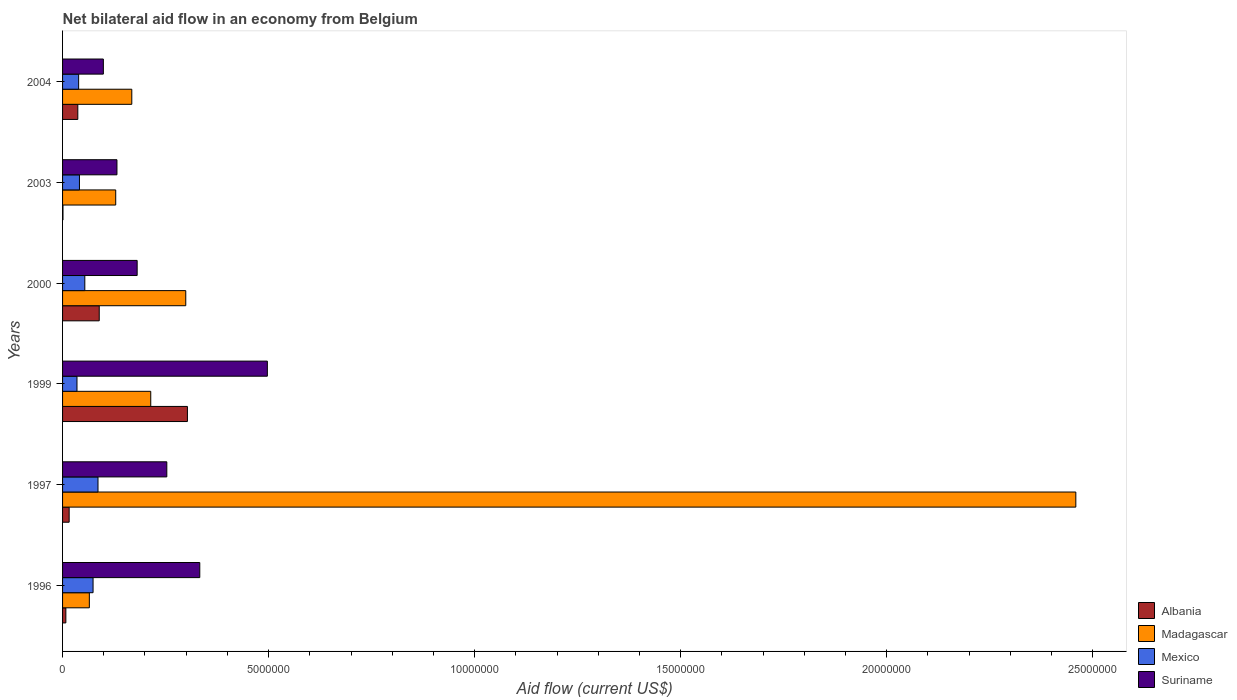How many different coloured bars are there?
Make the answer very short. 4. How many groups of bars are there?
Ensure brevity in your answer.  6. How many bars are there on the 1st tick from the top?
Ensure brevity in your answer.  4. What is the net bilateral aid flow in Mexico in 1996?
Your response must be concise. 7.40e+05. Across all years, what is the maximum net bilateral aid flow in Albania?
Ensure brevity in your answer.  3.03e+06. What is the total net bilateral aid flow in Albania in the graph?
Offer a very short reply. 4.54e+06. What is the difference between the net bilateral aid flow in Suriname in 1996 and that in 2003?
Give a very brief answer. 2.01e+06. What is the difference between the net bilateral aid flow in Madagascar in 2004 and the net bilateral aid flow in Albania in 1999?
Make the answer very short. -1.35e+06. What is the average net bilateral aid flow in Albania per year?
Provide a short and direct response. 7.57e+05. In the year 2003, what is the difference between the net bilateral aid flow in Mexico and net bilateral aid flow in Albania?
Keep it short and to the point. 4.00e+05. In how many years, is the net bilateral aid flow in Suriname greater than 5000000 US$?
Provide a short and direct response. 0. What is the ratio of the net bilateral aid flow in Suriname in 1997 to that in 2004?
Offer a very short reply. 2.56. What is the difference between the highest and the second highest net bilateral aid flow in Albania?
Make the answer very short. 2.14e+06. What is the difference between the highest and the lowest net bilateral aid flow in Madagascar?
Give a very brief answer. 2.39e+07. In how many years, is the net bilateral aid flow in Madagascar greater than the average net bilateral aid flow in Madagascar taken over all years?
Provide a succinct answer. 1. Is it the case that in every year, the sum of the net bilateral aid flow in Albania and net bilateral aid flow in Mexico is greater than the sum of net bilateral aid flow in Madagascar and net bilateral aid flow in Suriname?
Offer a very short reply. Yes. Is it the case that in every year, the sum of the net bilateral aid flow in Albania and net bilateral aid flow in Madagascar is greater than the net bilateral aid flow in Suriname?
Keep it short and to the point. No. How many bars are there?
Your response must be concise. 24. Are all the bars in the graph horizontal?
Provide a short and direct response. Yes. What is the difference between two consecutive major ticks on the X-axis?
Your response must be concise. 5.00e+06. Does the graph contain any zero values?
Make the answer very short. No. Where does the legend appear in the graph?
Your answer should be compact. Bottom right. How many legend labels are there?
Ensure brevity in your answer.  4. What is the title of the graph?
Offer a very short reply. Net bilateral aid flow in an economy from Belgium. What is the label or title of the Y-axis?
Offer a very short reply. Years. What is the Aid flow (current US$) in Albania in 1996?
Give a very brief answer. 8.00e+04. What is the Aid flow (current US$) in Madagascar in 1996?
Keep it short and to the point. 6.50e+05. What is the Aid flow (current US$) of Mexico in 1996?
Ensure brevity in your answer.  7.40e+05. What is the Aid flow (current US$) in Suriname in 1996?
Offer a terse response. 3.33e+06. What is the Aid flow (current US$) in Madagascar in 1997?
Ensure brevity in your answer.  2.46e+07. What is the Aid flow (current US$) in Mexico in 1997?
Your answer should be very brief. 8.60e+05. What is the Aid flow (current US$) in Suriname in 1997?
Provide a succinct answer. 2.53e+06. What is the Aid flow (current US$) of Albania in 1999?
Give a very brief answer. 3.03e+06. What is the Aid flow (current US$) of Madagascar in 1999?
Your response must be concise. 2.14e+06. What is the Aid flow (current US$) in Mexico in 1999?
Make the answer very short. 3.50e+05. What is the Aid flow (current US$) of Suriname in 1999?
Offer a very short reply. 4.97e+06. What is the Aid flow (current US$) of Albania in 2000?
Your answer should be very brief. 8.90e+05. What is the Aid flow (current US$) in Madagascar in 2000?
Make the answer very short. 2.99e+06. What is the Aid flow (current US$) in Mexico in 2000?
Offer a very short reply. 5.40e+05. What is the Aid flow (current US$) of Suriname in 2000?
Provide a succinct answer. 1.81e+06. What is the Aid flow (current US$) in Madagascar in 2003?
Give a very brief answer. 1.29e+06. What is the Aid flow (current US$) in Mexico in 2003?
Your response must be concise. 4.10e+05. What is the Aid flow (current US$) of Suriname in 2003?
Your response must be concise. 1.32e+06. What is the Aid flow (current US$) of Madagascar in 2004?
Provide a succinct answer. 1.68e+06. What is the Aid flow (current US$) of Suriname in 2004?
Provide a short and direct response. 9.90e+05. Across all years, what is the maximum Aid flow (current US$) in Albania?
Your answer should be compact. 3.03e+06. Across all years, what is the maximum Aid flow (current US$) in Madagascar?
Keep it short and to the point. 2.46e+07. Across all years, what is the maximum Aid flow (current US$) of Mexico?
Give a very brief answer. 8.60e+05. Across all years, what is the maximum Aid flow (current US$) in Suriname?
Your response must be concise. 4.97e+06. Across all years, what is the minimum Aid flow (current US$) in Madagascar?
Keep it short and to the point. 6.50e+05. Across all years, what is the minimum Aid flow (current US$) in Suriname?
Provide a succinct answer. 9.90e+05. What is the total Aid flow (current US$) in Albania in the graph?
Keep it short and to the point. 4.54e+06. What is the total Aid flow (current US$) of Madagascar in the graph?
Ensure brevity in your answer.  3.33e+07. What is the total Aid flow (current US$) in Mexico in the graph?
Offer a very short reply. 3.29e+06. What is the total Aid flow (current US$) of Suriname in the graph?
Ensure brevity in your answer.  1.50e+07. What is the difference between the Aid flow (current US$) of Madagascar in 1996 and that in 1997?
Your answer should be very brief. -2.39e+07. What is the difference between the Aid flow (current US$) in Suriname in 1996 and that in 1997?
Your answer should be very brief. 8.00e+05. What is the difference between the Aid flow (current US$) in Albania in 1996 and that in 1999?
Your answer should be compact. -2.95e+06. What is the difference between the Aid flow (current US$) in Madagascar in 1996 and that in 1999?
Provide a succinct answer. -1.49e+06. What is the difference between the Aid flow (current US$) of Mexico in 1996 and that in 1999?
Your response must be concise. 3.90e+05. What is the difference between the Aid flow (current US$) of Suriname in 1996 and that in 1999?
Offer a very short reply. -1.64e+06. What is the difference between the Aid flow (current US$) of Albania in 1996 and that in 2000?
Your answer should be compact. -8.10e+05. What is the difference between the Aid flow (current US$) of Madagascar in 1996 and that in 2000?
Ensure brevity in your answer.  -2.34e+06. What is the difference between the Aid flow (current US$) of Mexico in 1996 and that in 2000?
Ensure brevity in your answer.  2.00e+05. What is the difference between the Aid flow (current US$) in Suriname in 1996 and that in 2000?
Ensure brevity in your answer.  1.52e+06. What is the difference between the Aid flow (current US$) of Madagascar in 1996 and that in 2003?
Your answer should be compact. -6.40e+05. What is the difference between the Aid flow (current US$) of Suriname in 1996 and that in 2003?
Your response must be concise. 2.01e+06. What is the difference between the Aid flow (current US$) in Albania in 1996 and that in 2004?
Give a very brief answer. -2.90e+05. What is the difference between the Aid flow (current US$) of Madagascar in 1996 and that in 2004?
Your answer should be compact. -1.03e+06. What is the difference between the Aid flow (current US$) in Suriname in 1996 and that in 2004?
Ensure brevity in your answer.  2.34e+06. What is the difference between the Aid flow (current US$) of Albania in 1997 and that in 1999?
Provide a short and direct response. -2.87e+06. What is the difference between the Aid flow (current US$) in Madagascar in 1997 and that in 1999?
Your response must be concise. 2.24e+07. What is the difference between the Aid flow (current US$) of Mexico in 1997 and that in 1999?
Offer a very short reply. 5.10e+05. What is the difference between the Aid flow (current US$) in Suriname in 1997 and that in 1999?
Your response must be concise. -2.44e+06. What is the difference between the Aid flow (current US$) in Albania in 1997 and that in 2000?
Make the answer very short. -7.30e+05. What is the difference between the Aid flow (current US$) in Madagascar in 1997 and that in 2000?
Ensure brevity in your answer.  2.16e+07. What is the difference between the Aid flow (current US$) in Suriname in 1997 and that in 2000?
Your response must be concise. 7.20e+05. What is the difference between the Aid flow (current US$) in Madagascar in 1997 and that in 2003?
Give a very brief answer. 2.33e+07. What is the difference between the Aid flow (current US$) of Mexico in 1997 and that in 2003?
Ensure brevity in your answer.  4.50e+05. What is the difference between the Aid flow (current US$) of Suriname in 1997 and that in 2003?
Your response must be concise. 1.21e+06. What is the difference between the Aid flow (current US$) of Albania in 1997 and that in 2004?
Your answer should be very brief. -2.10e+05. What is the difference between the Aid flow (current US$) of Madagascar in 1997 and that in 2004?
Give a very brief answer. 2.29e+07. What is the difference between the Aid flow (current US$) in Suriname in 1997 and that in 2004?
Keep it short and to the point. 1.54e+06. What is the difference between the Aid flow (current US$) in Albania in 1999 and that in 2000?
Make the answer very short. 2.14e+06. What is the difference between the Aid flow (current US$) in Madagascar in 1999 and that in 2000?
Your answer should be very brief. -8.50e+05. What is the difference between the Aid flow (current US$) of Mexico in 1999 and that in 2000?
Your answer should be very brief. -1.90e+05. What is the difference between the Aid flow (current US$) of Suriname in 1999 and that in 2000?
Your answer should be very brief. 3.16e+06. What is the difference between the Aid flow (current US$) of Albania in 1999 and that in 2003?
Provide a short and direct response. 3.02e+06. What is the difference between the Aid flow (current US$) of Madagascar in 1999 and that in 2003?
Your answer should be compact. 8.50e+05. What is the difference between the Aid flow (current US$) in Suriname in 1999 and that in 2003?
Make the answer very short. 3.65e+06. What is the difference between the Aid flow (current US$) of Albania in 1999 and that in 2004?
Make the answer very short. 2.66e+06. What is the difference between the Aid flow (current US$) in Suriname in 1999 and that in 2004?
Offer a terse response. 3.98e+06. What is the difference between the Aid flow (current US$) of Albania in 2000 and that in 2003?
Keep it short and to the point. 8.80e+05. What is the difference between the Aid flow (current US$) of Madagascar in 2000 and that in 2003?
Provide a short and direct response. 1.70e+06. What is the difference between the Aid flow (current US$) of Suriname in 2000 and that in 2003?
Offer a terse response. 4.90e+05. What is the difference between the Aid flow (current US$) of Albania in 2000 and that in 2004?
Give a very brief answer. 5.20e+05. What is the difference between the Aid flow (current US$) of Madagascar in 2000 and that in 2004?
Make the answer very short. 1.31e+06. What is the difference between the Aid flow (current US$) in Suriname in 2000 and that in 2004?
Your response must be concise. 8.20e+05. What is the difference between the Aid flow (current US$) in Albania in 2003 and that in 2004?
Offer a very short reply. -3.60e+05. What is the difference between the Aid flow (current US$) of Madagascar in 2003 and that in 2004?
Provide a short and direct response. -3.90e+05. What is the difference between the Aid flow (current US$) in Mexico in 2003 and that in 2004?
Provide a short and direct response. 2.00e+04. What is the difference between the Aid flow (current US$) of Suriname in 2003 and that in 2004?
Provide a succinct answer. 3.30e+05. What is the difference between the Aid flow (current US$) in Albania in 1996 and the Aid flow (current US$) in Madagascar in 1997?
Your answer should be compact. -2.45e+07. What is the difference between the Aid flow (current US$) in Albania in 1996 and the Aid flow (current US$) in Mexico in 1997?
Give a very brief answer. -7.80e+05. What is the difference between the Aid flow (current US$) in Albania in 1996 and the Aid flow (current US$) in Suriname in 1997?
Give a very brief answer. -2.45e+06. What is the difference between the Aid flow (current US$) of Madagascar in 1996 and the Aid flow (current US$) of Suriname in 1997?
Your answer should be very brief. -1.88e+06. What is the difference between the Aid flow (current US$) of Mexico in 1996 and the Aid flow (current US$) of Suriname in 1997?
Provide a succinct answer. -1.79e+06. What is the difference between the Aid flow (current US$) in Albania in 1996 and the Aid flow (current US$) in Madagascar in 1999?
Provide a short and direct response. -2.06e+06. What is the difference between the Aid flow (current US$) of Albania in 1996 and the Aid flow (current US$) of Suriname in 1999?
Keep it short and to the point. -4.89e+06. What is the difference between the Aid flow (current US$) of Madagascar in 1996 and the Aid flow (current US$) of Suriname in 1999?
Your response must be concise. -4.32e+06. What is the difference between the Aid flow (current US$) of Mexico in 1996 and the Aid flow (current US$) of Suriname in 1999?
Your answer should be compact. -4.23e+06. What is the difference between the Aid flow (current US$) in Albania in 1996 and the Aid flow (current US$) in Madagascar in 2000?
Your answer should be very brief. -2.91e+06. What is the difference between the Aid flow (current US$) of Albania in 1996 and the Aid flow (current US$) of Mexico in 2000?
Offer a very short reply. -4.60e+05. What is the difference between the Aid flow (current US$) in Albania in 1996 and the Aid flow (current US$) in Suriname in 2000?
Provide a short and direct response. -1.73e+06. What is the difference between the Aid flow (current US$) in Madagascar in 1996 and the Aid flow (current US$) in Suriname in 2000?
Ensure brevity in your answer.  -1.16e+06. What is the difference between the Aid flow (current US$) in Mexico in 1996 and the Aid flow (current US$) in Suriname in 2000?
Give a very brief answer. -1.07e+06. What is the difference between the Aid flow (current US$) of Albania in 1996 and the Aid flow (current US$) of Madagascar in 2003?
Make the answer very short. -1.21e+06. What is the difference between the Aid flow (current US$) in Albania in 1996 and the Aid flow (current US$) in Mexico in 2003?
Keep it short and to the point. -3.30e+05. What is the difference between the Aid flow (current US$) in Albania in 1996 and the Aid flow (current US$) in Suriname in 2003?
Your answer should be very brief. -1.24e+06. What is the difference between the Aid flow (current US$) in Madagascar in 1996 and the Aid flow (current US$) in Suriname in 2003?
Ensure brevity in your answer.  -6.70e+05. What is the difference between the Aid flow (current US$) of Mexico in 1996 and the Aid flow (current US$) of Suriname in 2003?
Ensure brevity in your answer.  -5.80e+05. What is the difference between the Aid flow (current US$) in Albania in 1996 and the Aid flow (current US$) in Madagascar in 2004?
Give a very brief answer. -1.60e+06. What is the difference between the Aid flow (current US$) in Albania in 1996 and the Aid flow (current US$) in Mexico in 2004?
Your response must be concise. -3.10e+05. What is the difference between the Aid flow (current US$) in Albania in 1996 and the Aid flow (current US$) in Suriname in 2004?
Provide a succinct answer. -9.10e+05. What is the difference between the Aid flow (current US$) in Madagascar in 1996 and the Aid flow (current US$) in Mexico in 2004?
Give a very brief answer. 2.60e+05. What is the difference between the Aid flow (current US$) of Madagascar in 1996 and the Aid flow (current US$) of Suriname in 2004?
Provide a short and direct response. -3.40e+05. What is the difference between the Aid flow (current US$) of Mexico in 1996 and the Aid flow (current US$) of Suriname in 2004?
Offer a very short reply. -2.50e+05. What is the difference between the Aid flow (current US$) in Albania in 1997 and the Aid flow (current US$) in Madagascar in 1999?
Provide a short and direct response. -1.98e+06. What is the difference between the Aid flow (current US$) of Albania in 1997 and the Aid flow (current US$) of Mexico in 1999?
Ensure brevity in your answer.  -1.90e+05. What is the difference between the Aid flow (current US$) in Albania in 1997 and the Aid flow (current US$) in Suriname in 1999?
Make the answer very short. -4.81e+06. What is the difference between the Aid flow (current US$) of Madagascar in 1997 and the Aid flow (current US$) of Mexico in 1999?
Your answer should be compact. 2.42e+07. What is the difference between the Aid flow (current US$) of Madagascar in 1997 and the Aid flow (current US$) of Suriname in 1999?
Offer a terse response. 1.96e+07. What is the difference between the Aid flow (current US$) in Mexico in 1997 and the Aid flow (current US$) in Suriname in 1999?
Provide a short and direct response. -4.11e+06. What is the difference between the Aid flow (current US$) of Albania in 1997 and the Aid flow (current US$) of Madagascar in 2000?
Keep it short and to the point. -2.83e+06. What is the difference between the Aid flow (current US$) of Albania in 1997 and the Aid flow (current US$) of Mexico in 2000?
Keep it short and to the point. -3.80e+05. What is the difference between the Aid flow (current US$) in Albania in 1997 and the Aid flow (current US$) in Suriname in 2000?
Your response must be concise. -1.65e+06. What is the difference between the Aid flow (current US$) in Madagascar in 1997 and the Aid flow (current US$) in Mexico in 2000?
Provide a succinct answer. 2.40e+07. What is the difference between the Aid flow (current US$) in Madagascar in 1997 and the Aid flow (current US$) in Suriname in 2000?
Your answer should be compact. 2.28e+07. What is the difference between the Aid flow (current US$) of Mexico in 1997 and the Aid flow (current US$) of Suriname in 2000?
Ensure brevity in your answer.  -9.50e+05. What is the difference between the Aid flow (current US$) of Albania in 1997 and the Aid flow (current US$) of Madagascar in 2003?
Keep it short and to the point. -1.13e+06. What is the difference between the Aid flow (current US$) of Albania in 1997 and the Aid flow (current US$) of Mexico in 2003?
Make the answer very short. -2.50e+05. What is the difference between the Aid flow (current US$) of Albania in 1997 and the Aid flow (current US$) of Suriname in 2003?
Your answer should be compact. -1.16e+06. What is the difference between the Aid flow (current US$) of Madagascar in 1997 and the Aid flow (current US$) of Mexico in 2003?
Keep it short and to the point. 2.42e+07. What is the difference between the Aid flow (current US$) of Madagascar in 1997 and the Aid flow (current US$) of Suriname in 2003?
Offer a very short reply. 2.33e+07. What is the difference between the Aid flow (current US$) in Mexico in 1997 and the Aid flow (current US$) in Suriname in 2003?
Offer a terse response. -4.60e+05. What is the difference between the Aid flow (current US$) in Albania in 1997 and the Aid flow (current US$) in Madagascar in 2004?
Your answer should be compact. -1.52e+06. What is the difference between the Aid flow (current US$) in Albania in 1997 and the Aid flow (current US$) in Suriname in 2004?
Your response must be concise. -8.30e+05. What is the difference between the Aid flow (current US$) in Madagascar in 1997 and the Aid flow (current US$) in Mexico in 2004?
Keep it short and to the point. 2.42e+07. What is the difference between the Aid flow (current US$) in Madagascar in 1997 and the Aid flow (current US$) in Suriname in 2004?
Keep it short and to the point. 2.36e+07. What is the difference between the Aid flow (current US$) in Mexico in 1997 and the Aid flow (current US$) in Suriname in 2004?
Provide a succinct answer. -1.30e+05. What is the difference between the Aid flow (current US$) in Albania in 1999 and the Aid flow (current US$) in Madagascar in 2000?
Your response must be concise. 4.00e+04. What is the difference between the Aid flow (current US$) in Albania in 1999 and the Aid flow (current US$) in Mexico in 2000?
Keep it short and to the point. 2.49e+06. What is the difference between the Aid flow (current US$) of Albania in 1999 and the Aid flow (current US$) of Suriname in 2000?
Ensure brevity in your answer.  1.22e+06. What is the difference between the Aid flow (current US$) in Madagascar in 1999 and the Aid flow (current US$) in Mexico in 2000?
Keep it short and to the point. 1.60e+06. What is the difference between the Aid flow (current US$) in Mexico in 1999 and the Aid flow (current US$) in Suriname in 2000?
Your response must be concise. -1.46e+06. What is the difference between the Aid flow (current US$) of Albania in 1999 and the Aid flow (current US$) of Madagascar in 2003?
Provide a short and direct response. 1.74e+06. What is the difference between the Aid flow (current US$) in Albania in 1999 and the Aid flow (current US$) in Mexico in 2003?
Give a very brief answer. 2.62e+06. What is the difference between the Aid flow (current US$) of Albania in 1999 and the Aid flow (current US$) of Suriname in 2003?
Ensure brevity in your answer.  1.71e+06. What is the difference between the Aid flow (current US$) of Madagascar in 1999 and the Aid flow (current US$) of Mexico in 2003?
Offer a terse response. 1.73e+06. What is the difference between the Aid flow (current US$) of Madagascar in 1999 and the Aid flow (current US$) of Suriname in 2003?
Your answer should be very brief. 8.20e+05. What is the difference between the Aid flow (current US$) in Mexico in 1999 and the Aid flow (current US$) in Suriname in 2003?
Provide a short and direct response. -9.70e+05. What is the difference between the Aid flow (current US$) in Albania in 1999 and the Aid flow (current US$) in Madagascar in 2004?
Make the answer very short. 1.35e+06. What is the difference between the Aid flow (current US$) of Albania in 1999 and the Aid flow (current US$) of Mexico in 2004?
Provide a succinct answer. 2.64e+06. What is the difference between the Aid flow (current US$) in Albania in 1999 and the Aid flow (current US$) in Suriname in 2004?
Your response must be concise. 2.04e+06. What is the difference between the Aid flow (current US$) in Madagascar in 1999 and the Aid flow (current US$) in Mexico in 2004?
Keep it short and to the point. 1.75e+06. What is the difference between the Aid flow (current US$) in Madagascar in 1999 and the Aid flow (current US$) in Suriname in 2004?
Keep it short and to the point. 1.15e+06. What is the difference between the Aid flow (current US$) of Mexico in 1999 and the Aid flow (current US$) of Suriname in 2004?
Your answer should be very brief. -6.40e+05. What is the difference between the Aid flow (current US$) in Albania in 2000 and the Aid flow (current US$) in Madagascar in 2003?
Keep it short and to the point. -4.00e+05. What is the difference between the Aid flow (current US$) of Albania in 2000 and the Aid flow (current US$) of Mexico in 2003?
Give a very brief answer. 4.80e+05. What is the difference between the Aid flow (current US$) in Albania in 2000 and the Aid flow (current US$) in Suriname in 2003?
Your response must be concise. -4.30e+05. What is the difference between the Aid flow (current US$) in Madagascar in 2000 and the Aid flow (current US$) in Mexico in 2003?
Your answer should be very brief. 2.58e+06. What is the difference between the Aid flow (current US$) in Madagascar in 2000 and the Aid flow (current US$) in Suriname in 2003?
Your answer should be compact. 1.67e+06. What is the difference between the Aid flow (current US$) of Mexico in 2000 and the Aid flow (current US$) of Suriname in 2003?
Provide a succinct answer. -7.80e+05. What is the difference between the Aid flow (current US$) in Albania in 2000 and the Aid flow (current US$) in Madagascar in 2004?
Offer a very short reply. -7.90e+05. What is the difference between the Aid flow (current US$) of Albania in 2000 and the Aid flow (current US$) of Mexico in 2004?
Your answer should be very brief. 5.00e+05. What is the difference between the Aid flow (current US$) of Madagascar in 2000 and the Aid flow (current US$) of Mexico in 2004?
Your response must be concise. 2.60e+06. What is the difference between the Aid flow (current US$) of Mexico in 2000 and the Aid flow (current US$) of Suriname in 2004?
Offer a terse response. -4.50e+05. What is the difference between the Aid flow (current US$) of Albania in 2003 and the Aid flow (current US$) of Madagascar in 2004?
Provide a short and direct response. -1.67e+06. What is the difference between the Aid flow (current US$) in Albania in 2003 and the Aid flow (current US$) in Mexico in 2004?
Provide a short and direct response. -3.80e+05. What is the difference between the Aid flow (current US$) in Albania in 2003 and the Aid flow (current US$) in Suriname in 2004?
Your answer should be very brief. -9.80e+05. What is the difference between the Aid flow (current US$) in Madagascar in 2003 and the Aid flow (current US$) in Suriname in 2004?
Offer a terse response. 3.00e+05. What is the difference between the Aid flow (current US$) of Mexico in 2003 and the Aid flow (current US$) of Suriname in 2004?
Your answer should be compact. -5.80e+05. What is the average Aid flow (current US$) of Albania per year?
Ensure brevity in your answer.  7.57e+05. What is the average Aid flow (current US$) in Madagascar per year?
Give a very brief answer. 5.56e+06. What is the average Aid flow (current US$) of Mexico per year?
Provide a short and direct response. 5.48e+05. What is the average Aid flow (current US$) of Suriname per year?
Your response must be concise. 2.49e+06. In the year 1996, what is the difference between the Aid flow (current US$) in Albania and Aid flow (current US$) in Madagascar?
Provide a short and direct response. -5.70e+05. In the year 1996, what is the difference between the Aid flow (current US$) in Albania and Aid flow (current US$) in Mexico?
Give a very brief answer. -6.60e+05. In the year 1996, what is the difference between the Aid flow (current US$) in Albania and Aid flow (current US$) in Suriname?
Keep it short and to the point. -3.25e+06. In the year 1996, what is the difference between the Aid flow (current US$) in Madagascar and Aid flow (current US$) in Suriname?
Offer a terse response. -2.68e+06. In the year 1996, what is the difference between the Aid flow (current US$) of Mexico and Aid flow (current US$) of Suriname?
Keep it short and to the point. -2.59e+06. In the year 1997, what is the difference between the Aid flow (current US$) of Albania and Aid flow (current US$) of Madagascar?
Your answer should be compact. -2.44e+07. In the year 1997, what is the difference between the Aid flow (current US$) in Albania and Aid flow (current US$) in Mexico?
Provide a short and direct response. -7.00e+05. In the year 1997, what is the difference between the Aid flow (current US$) in Albania and Aid flow (current US$) in Suriname?
Ensure brevity in your answer.  -2.37e+06. In the year 1997, what is the difference between the Aid flow (current US$) in Madagascar and Aid flow (current US$) in Mexico?
Give a very brief answer. 2.37e+07. In the year 1997, what is the difference between the Aid flow (current US$) of Madagascar and Aid flow (current US$) of Suriname?
Your response must be concise. 2.21e+07. In the year 1997, what is the difference between the Aid flow (current US$) in Mexico and Aid flow (current US$) in Suriname?
Your answer should be compact. -1.67e+06. In the year 1999, what is the difference between the Aid flow (current US$) of Albania and Aid flow (current US$) of Madagascar?
Ensure brevity in your answer.  8.90e+05. In the year 1999, what is the difference between the Aid flow (current US$) in Albania and Aid flow (current US$) in Mexico?
Your answer should be compact. 2.68e+06. In the year 1999, what is the difference between the Aid flow (current US$) in Albania and Aid flow (current US$) in Suriname?
Ensure brevity in your answer.  -1.94e+06. In the year 1999, what is the difference between the Aid flow (current US$) in Madagascar and Aid flow (current US$) in Mexico?
Offer a very short reply. 1.79e+06. In the year 1999, what is the difference between the Aid flow (current US$) of Madagascar and Aid flow (current US$) of Suriname?
Offer a very short reply. -2.83e+06. In the year 1999, what is the difference between the Aid flow (current US$) in Mexico and Aid flow (current US$) in Suriname?
Your response must be concise. -4.62e+06. In the year 2000, what is the difference between the Aid flow (current US$) in Albania and Aid flow (current US$) in Madagascar?
Give a very brief answer. -2.10e+06. In the year 2000, what is the difference between the Aid flow (current US$) of Albania and Aid flow (current US$) of Suriname?
Give a very brief answer. -9.20e+05. In the year 2000, what is the difference between the Aid flow (current US$) in Madagascar and Aid flow (current US$) in Mexico?
Provide a short and direct response. 2.45e+06. In the year 2000, what is the difference between the Aid flow (current US$) in Madagascar and Aid flow (current US$) in Suriname?
Ensure brevity in your answer.  1.18e+06. In the year 2000, what is the difference between the Aid flow (current US$) in Mexico and Aid flow (current US$) in Suriname?
Make the answer very short. -1.27e+06. In the year 2003, what is the difference between the Aid flow (current US$) of Albania and Aid flow (current US$) of Madagascar?
Provide a short and direct response. -1.28e+06. In the year 2003, what is the difference between the Aid flow (current US$) of Albania and Aid flow (current US$) of Mexico?
Provide a succinct answer. -4.00e+05. In the year 2003, what is the difference between the Aid flow (current US$) of Albania and Aid flow (current US$) of Suriname?
Your answer should be compact. -1.31e+06. In the year 2003, what is the difference between the Aid flow (current US$) in Madagascar and Aid flow (current US$) in Mexico?
Keep it short and to the point. 8.80e+05. In the year 2003, what is the difference between the Aid flow (current US$) of Mexico and Aid flow (current US$) of Suriname?
Provide a succinct answer. -9.10e+05. In the year 2004, what is the difference between the Aid flow (current US$) of Albania and Aid flow (current US$) of Madagascar?
Your answer should be very brief. -1.31e+06. In the year 2004, what is the difference between the Aid flow (current US$) of Albania and Aid flow (current US$) of Mexico?
Provide a succinct answer. -2.00e+04. In the year 2004, what is the difference between the Aid flow (current US$) of Albania and Aid flow (current US$) of Suriname?
Offer a terse response. -6.20e+05. In the year 2004, what is the difference between the Aid flow (current US$) of Madagascar and Aid flow (current US$) of Mexico?
Your answer should be compact. 1.29e+06. In the year 2004, what is the difference between the Aid flow (current US$) of Madagascar and Aid flow (current US$) of Suriname?
Your response must be concise. 6.90e+05. In the year 2004, what is the difference between the Aid flow (current US$) in Mexico and Aid flow (current US$) in Suriname?
Provide a succinct answer. -6.00e+05. What is the ratio of the Aid flow (current US$) of Albania in 1996 to that in 1997?
Keep it short and to the point. 0.5. What is the ratio of the Aid flow (current US$) of Madagascar in 1996 to that in 1997?
Offer a terse response. 0.03. What is the ratio of the Aid flow (current US$) of Mexico in 1996 to that in 1997?
Make the answer very short. 0.86. What is the ratio of the Aid flow (current US$) of Suriname in 1996 to that in 1997?
Your answer should be very brief. 1.32. What is the ratio of the Aid flow (current US$) in Albania in 1996 to that in 1999?
Ensure brevity in your answer.  0.03. What is the ratio of the Aid flow (current US$) of Madagascar in 1996 to that in 1999?
Offer a terse response. 0.3. What is the ratio of the Aid flow (current US$) in Mexico in 1996 to that in 1999?
Provide a short and direct response. 2.11. What is the ratio of the Aid flow (current US$) in Suriname in 1996 to that in 1999?
Provide a short and direct response. 0.67. What is the ratio of the Aid flow (current US$) in Albania in 1996 to that in 2000?
Your response must be concise. 0.09. What is the ratio of the Aid flow (current US$) in Madagascar in 1996 to that in 2000?
Your response must be concise. 0.22. What is the ratio of the Aid flow (current US$) of Mexico in 1996 to that in 2000?
Offer a terse response. 1.37. What is the ratio of the Aid flow (current US$) in Suriname in 1996 to that in 2000?
Provide a succinct answer. 1.84. What is the ratio of the Aid flow (current US$) of Madagascar in 1996 to that in 2003?
Offer a terse response. 0.5. What is the ratio of the Aid flow (current US$) of Mexico in 1996 to that in 2003?
Provide a succinct answer. 1.8. What is the ratio of the Aid flow (current US$) of Suriname in 1996 to that in 2003?
Offer a very short reply. 2.52. What is the ratio of the Aid flow (current US$) in Albania in 1996 to that in 2004?
Your answer should be very brief. 0.22. What is the ratio of the Aid flow (current US$) in Madagascar in 1996 to that in 2004?
Offer a terse response. 0.39. What is the ratio of the Aid flow (current US$) of Mexico in 1996 to that in 2004?
Provide a short and direct response. 1.9. What is the ratio of the Aid flow (current US$) in Suriname in 1996 to that in 2004?
Ensure brevity in your answer.  3.36. What is the ratio of the Aid flow (current US$) in Albania in 1997 to that in 1999?
Provide a succinct answer. 0.05. What is the ratio of the Aid flow (current US$) of Madagascar in 1997 to that in 1999?
Keep it short and to the point. 11.49. What is the ratio of the Aid flow (current US$) in Mexico in 1997 to that in 1999?
Make the answer very short. 2.46. What is the ratio of the Aid flow (current US$) of Suriname in 1997 to that in 1999?
Ensure brevity in your answer.  0.51. What is the ratio of the Aid flow (current US$) of Albania in 1997 to that in 2000?
Make the answer very short. 0.18. What is the ratio of the Aid flow (current US$) in Madagascar in 1997 to that in 2000?
Offer a terse response. 8.22. What is the ratio of the Aid flow (current US$) of Mexico in 1997 to that in 2000?
Offer a terse response. 1.59. What is the ratio of the Aid flow (current US$) in Suriname in 1997 to that in 2000?
Keep it short and to the point. 1.4. What is the ratio of the Aid flow (current US$) in Albania in 1997 to that in 2003?
Your answer should be compact. 16. What is the ratio of the Aid flow (current US$) in Madagascar in 1997 to that in 2003?
Offer a very short reply. 19.06. What is the ratio of the Aid flow (current US$) of Mexico in 1997 to that in 2003?
Make the answer very short. 2.1. What is the ratio of the Aid flow (current US$) of Suriname in 1997 to that in 2003?
Your response must be concise. 1.92. What is the ratio of the Aid flow (current US$) in Albania in 1997 to that in 2004?
Ensure brevity in your answer.  0.43. What is the ratio of the Aid flow (current US$) of Madagascar in 1997 to that in 2004?
Offer a terse response. 14.64. What is the ratio of the Aid flow (current US$) in Mexico in 1997 to that in 2004?
Provide a short and direct response. 2.21. What is the ratio of the Aid flow (current US$) in Suriname in 1997 to that in 2004?
Ensure brevity in your answer.  2.56. What is the ratio of the Aid flow (current US$) of Albania in 1999 to that in 2000?
Your answer should be compact. 3.4. What is the ratio of the Aid flow (current US$) in Madagascar in 1999 to that in 2000?
Your answer should be compact. 0.72. What is the ratio of the Aid flow (current US$) in Mexico in 1999 to that in 2000?
Make the answer very short. 0.65. What is the ratio of the Aid flow (current US$) in Suriname in 1999 to that in 2000?
Offer a very short reply. 2.75. What is the ratio of the Aid flow (current US$) in Albania in 1999 to that in 2003?
Your answer should be compact. 303. What is the ratio of the Aid flow (current US$) in Madagascar in 1999 to that in 2003?
Ensure brevity in your answer.  1.66. What is the ratio of the Aid flow (current US$) of Mexico in 1999 to that in 2003?
Your response must be concise. 0.85. What is the ratio of the Aid flow (current US$) in Suriname in 1999 to that in 2003?
Your answer should be compact. 3.77. What is the ratio of the Aid flow (current US$) of Albania in 1999 to that in 2004?
Your answer should be compact. 8.19. What is the ratio of the Aid flow (current US$) in Madagascar in 1999 to that in 2004?
Give a very brief answer. 1.27. What is the ratio of the Aid flow (current US$) in Mexico in 1999 to that in 2004?
Provide a short and direct response. 0.9. What is the ratio of the Aid flow (current US$) of Suriname in 1999 to that in 2004?
Keep it short and to the point. 5.02. What is the ratio of the Aid flow (current US$) of Albania in 2000 to that in 2003?
Make the answer very short. 89. What is the ratio of the Aid flow (current US$) of Madagascar in 2000 to that in 2003?
Provide a succinct answer. 2.32. What is the ratio of the Aid flow (current US$) of Mexico in 2000 to that in 2003?
Offer a terse response. 1.32. What is the ratio of the Aid flow (current US$) of Suriname in 2000 to that in 2003?
Provide a succinct answer. 1.37. What is the ratio of the Aid flow (current US$) in Albania in 2000 to that in 2004?
Provide a succinct answer. 2.41. What is the ratio of the Aid flow (current US$) in Madagascar in 2000 to that in 2004?
Offer a very short reply. 1.78. What is the ratio of the Aid flow (current US$) in Mexico in 2000 to that in 2004?
Your response must be concise. 1.38. What is the ratio of the Aid flow (current US$) in Suriname in 2000 to that in 2004?
Your answer should be very brief. 1.83. What is the ratio of the Aid flow (current US$) in Albania in 2003 to that in 2004?
Ensure brevity in your answer.  0.03. What is the ratio of the Aid flow (current US$) in Madagascar in 2003 to that in 2004?
Keep it short and to the point. 0.77. What is the ratio of the Aid flow (current US$) in Mexico in 2003 to that in 2004?
Your answer should be compact. 1.05. What is the ratio of the Aid flow (current US$) of Suriname in 2003 to that in 2004?
Make the answer very short. 1.33. What is the difference between the highest and the second highest Aid flow (current US$) of Albania?
Provide a succinct answer. 2.14e+06. What is the difference between the highest and the second highest Aid flow (current US$) in Madagascar?
Your response must be concise. 2.16e+07. What is the difference between the highest and the second highest Aid flow (current US$) of Suriname?
Provide a succinct answer. 1.64e+06. What is the difference between the highest and the lowest Aid flow (current US$) of Albania?
Give a very brief answer. 3.02e+06. What is the difference between the highest and the lowest Aid flow (current US$) in Madagascar?
Give a very brief answer. 2.39e+07. What is the difference between the highest and the lowest Aid flow (current US$) of Mexico?
Your answer should be compact. 5.10e+05. What is the difference between the highest and the lowest Aid flow (current US$) in Suriname?
Provide a succinct answer. 3.98e+06. 